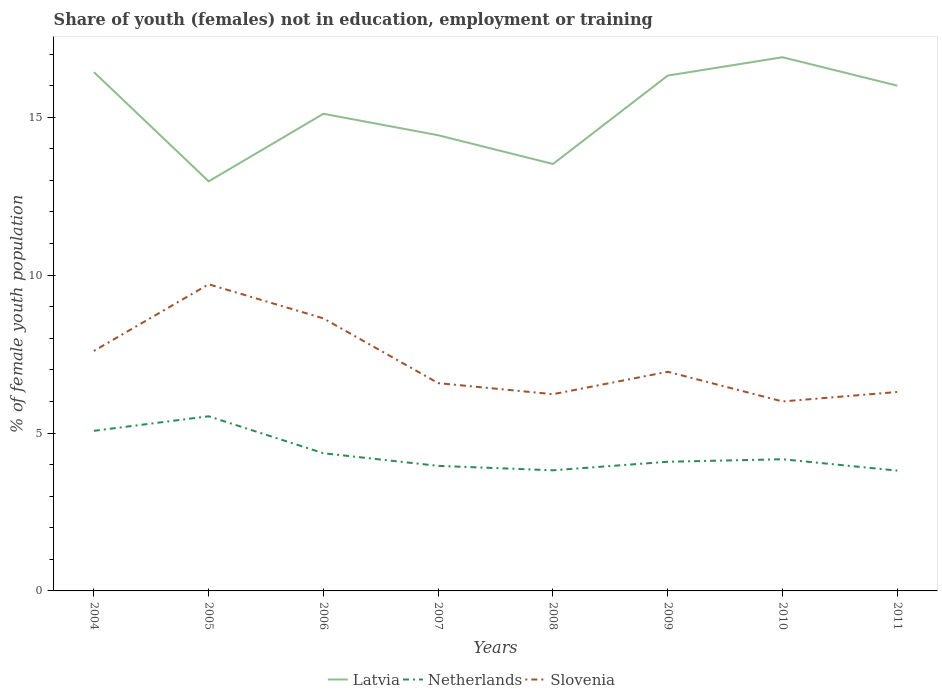Is the number of lines equal to the number of legend labels?
Offer a very short reply. Yes. Across all years, what is the maximum percentage of unemployed female population in in Latvia?
Ensure brevity in your answer.  12.97. In which year was the percentage of unemployed female population in in Slovenia maximum?
Offer a very short reply. 2010. What is the total percentage of unemployed female population in in Latvia in the graph?
Provide a succinct answer. 2.91. What is the difference between the highest and the second highest percentage of unemployed female population in in Netherlands?
Your response must be concise. 1.72. What is the difference between the highest and the lowest percentage of unemployed female population in in Netherlands?
Your answer should be very brief. 3. How many lines are there?
Offer a terse response. 3. How many years are there in the graph?
Provide a succinct answer. 8. What is the difference between two consecutive major ticks on the Y-axis?
Your answer should be compact. 5. Does the graph contain any zero values?
Offer a very short reply. No. Where does the legend appear in the graph?
Provide a succinct answer. Bottom center. How many legend labels are there?
Offer a terse response. 3. What is the title of the graph?
Provide a succinct answer. Share of youth (females) not in education, employment or training. Does "Barbados" appear as one of the legend labels in the graph?
Ensure brevity in your answer.  No. What is the label or title of the Y-axis?
Your answer should be compact. % of female youth population. What is the % of female youth population in Latvia in 2004?
Provide a short and direct response. 16.43. What is the % of female youth population of Netherlands in 2004?
Ensure brevity in your answer.  5.07. What is the % of female youth population in Slovenia in 2004?
Keep it short and to the point. 7.6. What is the % of female youth population in Latvia in 2005?
Make the answer very short. 12.97. What is the % of female youth population in Netherlands in 2005?
Ensure brevity in your answer.  5.53. What is the % of female youth population in Slovenia in 2005?
Provide a short and direct response. 9.71. What is the % of female youth population in Latvia in 2006?
Your answer should be very brief. 15.11. What is the % of female youth population of Netherlands in 2006?
Keep it short and to the point. 4.36. What is the % of female youth population of Slovenia in 2006?
Your response must be concise. 8.63. What is the % of female youth population of Latvia in 2007?
Provide a succinct answer. 14.43. What is the % of female youth population in Netherlands in 2007?
Provide a succinct answer. 3.96. What is the % of female youth population of Slovenia in 2007?
Keep it short and to the point. 6.58. What is the % of female youth population of Latvia in 2008?
Make the answer very short. 13.52. What is the % of female youth population of Netherlands in 2008?
Give a very brief answer. 3.82. What is the % of female youth population in Slovenia in 2008?
Your response must be concise. 6.23. What is the % of female youth population of Latvia in 2009?
Provide a short and direct response. 16.32. What is the % of female youth population in Netherlands in 2009?
Ensure brevity in your answer.  4.09. What is the % of female youth population of Slovenia in 2009?
Your answer should be compact. 6.94. What is the % of female youth population in Latvia in 2010?
Offer a very short reply. 16.9. What is the % of female youth population of Netherlands in 2010?
Offer a very short reply. 4.17. What is the % of female youth population of Slovenia in 2010?
Give a very brief answer. 6. What is the % of female youth population of Latvia in 2011?
Make the answer very short. 16. What is the % of female youth population of Netherlands in 2011?
Give a very brief answer. 3.81. What is the % of female youth population in Slovenia in 2011?
Offer a very short reply. 6.3. Across all years, what is the maximum % of female youth population of Latvia?
Provide a succinct answer. 16.9. Across all years, what is the maximum % of female youth population of Netherlands?
Keep it short and to the point. 5.53. Across all years, what is the maximum % of female youth population of Slovenia?
Provide a succinct answer. 9.71. Across all years, what is the minimum % of female youth population of Latvia?
Offer a terse response. 12.97. Across all years, what is the minimum % of female youth population of Netherlands?
Your answer should be very brief. 3.81. What is the total % of female youth population of Latvia in the graph?
Give a very brief answer. 121.68. What is the total % of female youth population in Netherlands in the graph?
Ensure brevity in your answer.  34.81. What is the total % of female youth population of Slovenia in the graph?
Ensure brevity in your answer.  57.99. What is the difference between the % of female youth population in Latvia in 2004 and that in 2005?
Your answer should be compact. 3.46. What is the difference between the % of female youth population in Netherlands in 2004 and that in 2005?
Keep it short and to the point. -0.46. What is the difference between the % of female youth population in Slovenia in 2004 and that in 2005?
Make the answer very short. -2.11. What is the difference between the % of female youth population in Latvia in 2004 and that in 2006?
Offer a very short reply. 1.32. What is the difference between the % of female youth population in Netherlands in 2004 and that in 2006?
Your response must be concise. 0.71. What is the difference between the % of female youth population of Slovenia in 2004 and that in 2006?
Make the answer very short. -1.03. What is the difference between the % of female youth population in Netherlands in 2004 and that in 2007?
Provide a succinct answer. 1.11. What is the difference between the % of female youth population in Latvia in 2004 and that in 2008?
Your response must be concise. 2.91. What is the difference between the % of female youth population in Slovenia in 2004 and that in 2008?
Provide a succinct answer. 1.37. What is the difference between the % of female youth population in Latvia in 2004 and that in 2009?
Ensure brevity in your answer.  0.11. What is the difference between the % of female youth population of Netherlands in 2004 and that in 2009?
Give a very brief answer. 0.98. What is the difference between the % of female youth population of Slovenia in 2004 and that in 2009?
Keep it short and to the point. 0.66. What is the difference between the % of female youth population of Latvia in 2004 and that in 2010?
Offer a terse response. -0.47. What is the difference between the % of female youth population of Netherlands in 2004 and that in 2010?
Provide a succinct answer. 0.9. What is the difference between the % of female youth population in Latvia in 2004 and that in 2011?
Offer a terse response. 0.43. What is the difference between the % of female youth population of Netherlands in 2004 and that in 2011?
Offer a terse response. 1.26. What is the difference between the % of female youth population of Slovenia in 2004 and that in 2011?
Keep it short and to the point. 1.3. What is the difference between the % of female youth population in Latvia in 2005 and that in 2006?
Give a very brief answer. -2.14. What is the difference between the % of female youth population of Netherlands in 2005 and that in 2006?
Offer a terse response. 1.17. What is the difference between the % of female youth population of Latvia in 2005 and that in 2007?
Your answer should be very brief. -1.46. What is the difference between the % of female youth population in Netherlands in 2005 and that in 2007?
Offer a terse response. 1.57. What is the difference between the % of female youth population in Slovenia in 2005 and that in 2007?
Offer a very short reply. 3.13. What is the difference between the % of female youth population in Latvia in 2005 and that in 2008?
Make the answer very short. -0.55. What is the difference between the % of female youth population in Netherlands in 2005 and that in 2008?
Provide a succinct answer. 1.71. What is the difference between the % of female youth population of Slovenia in 2005 and that in 2008?
Provide a short and direct response. 3.48. What is the difference between the % of female youth population in Latvia in 2005 and that in 2009?
Offer a very short reply. -3.35. What is the difference between the % of female youth population of Netherlands in 2005 and that in 2009?
Your answer should be compact. 1.44. What is the difference between the % of female youth population in Slovenia in 2005 and that in 2009?
Offer a very short reply. 2.77. What is the difference between the % of female youth population of Latvia in 2005 and that in 2010?
Offer a very short reply. -3.93. What is the difference between the % of female youth population of Netherlands in 2005 and that in 2010?
Offer a terse response. 1.36. What is the difference between the % of female youth population in Slovenia in 2005 and that in 2010?
Provide a succinct answer. 3.71. What is the difference between the % of female youth population of Latvia in 2005 and that in 2011?
Provide a short and direct response. -3.03. What is the difference between the % of female youth population in Netherlands in 2005 and that in 2011?
Provide a succinct answer. 1.72. What is the difference between the % of female youth population in Slovenia in 2005 and that in 2011?
Offer a very short reply. 3.41. What is the difference between the % of female youth population of Latvia in 2006 and that in 2007?
Keep it short and to the point. 0.68. What is the difference between the % of female youth population in Slovenia in 2006 and that in 2007?
Offer a terse response. 2.05. What is the difference between the % of female youth population in Latvia in 2006 and that in 2008?
Provide a succinct answer. 1.59. What is the difference between the % of female youth population in Netherlands in 2006 and that in 2008?
Keep it short and to the point. 0.54. What is the difference between the % of female youth population of Slovenia in 2006 and that in 2008?
Give a very brief answer. 2.4. What is the difference between the % of female youth population in Latvia in 2006 and that in 2009?
Your response must be concise. -1.21. What is the difference between the % of female youth population in Netherlands in 2006 and that in 2009?
Give a very brief answer. 0.27. What is the difference between the % of female youth population of Slovenia in 2006 and that in 2009?
Offer a very short reply. 1.69. What is the difference between the % of female youth population of Latvia in 2006 and that in 2010?
Your answer should be compact. -1.79. What is the difference between the % of female youth population in Netherlands in 2006 and that in 2010?
Your answer should be compact. 0.19. What is the difference between the % of female youth population in Slovenia in 2006 and that in 2010?
Give a very brief answer. 2.63. What is the difference between the % of female youth population of Latvia in 2006 and that in 2011?
Offer a terse response. -0.89. What is the difference between the % of female youth population in Netherlands in 2006 and that in 2011?
Your answer should be very brief. 0.55. What is the difference between the % of female youth population of Slovenia in 2006 and that in 2011?
Offer a terse response. 2.33. What is the difference between the % of female youth population of Latvia in 2007 and that in 2008?
Keep it short and to the point. 0.91. What is the difference between the % of female youth population in Netherlands in 2007 and that in 2008?
Your answer should be very brief. 0.14. What is the difference between the % of female youth population in Slovenia in 2007 and that in 2008?
Give a very brief answer. 0.35. What is the difference between the % of female youth population of Latvia in 2007 and that in 2009?
Provide a succinct answer. -1.89. What is the difference between the % of female youth population of Netherlands in 2007 and that in 2009?
Ensure brevity in your answer.  -0.13. What is the difference between the % of female youth population in Slovenia in 2007 and that in 2009?
Keep it short and to the point. -0.36. What is the difference between the % of female youth population in Latvia in 2007 and that in 2010?
Keep it short and to the point. -2.47. What is the difference between the % of female youth population of Netherlands in 2007 and that in 2010?
Offer a terse response. -0.21. What is the difference between the % of female youth population of Slovenia in 2007 and that in 2010?
Your answer should be compact. 0.58. What is the difference between the % of female youth population of Latvia in 2007 and that in 2011?
Ensure brevity in your answer.  -1.57. What is the difference between the % of female youth population of Slovenia in 2007 and that in 2011?
Make the answer very short. 0.28. What is the difference between the % of female youth population in Netherlands in 2008 and that in 2009?
Your response must be concise. -0.27. What is the difference between the % of female youth population in Slovenia in 2008 and that in 2009?
Your response must be concise. -0.71. What is the difference between the % of female youth population in Latvia in 2008 and that in 2010?
Provide a short and direct response. -3.38. What is the difference between the % of female youth population of Netherlands in 2008 and that in 2010?
Ensure brevity in your answer.  -0.35. What is the difference between the % of female youth population in Slovenia in 2008 and that in 2010?
Keep it short and to the point. 0.23. What is the difference between the % of female youth population of Latvia in 2008 and that in 2011?
Your answer should be compact. -2.48. What is the difference between the % of female youth population of Slovenia in 2008 and that in 2011?
Your response must be concise. -0.07. What is the difference between the % of female youth population in Latvia in 2009 and that in 2010?
Offer a terse response. -0.58. What is the difference between the % of female youth population in Netherlands in 2009 and that in 2010?
Offer a terse response. -0.08. What is the difference between the % of female youth population of Slovenia in 2009 and that in 2010?
Keep it short and to the point. 0.94. What is the difference between the % of female youth population in Latvia in 2009 and that in 2011?
Ensure brevity in your answer.  0.32. What is the difference between the % of female youth population of Netherlands in 2009 and that in 2011?
Provide a succinct answer. 0.28. What is the difference between the % of female youth population of Slovenia in 2009 and that in 2011?
Your response must be concise. 0.64. What is the difference between the % of female youth population in Netherlands in 2010 and that in 2011?
Provide a short and direct response. 0.36. What is the difference between the % of female youth population of Slovenia in 2010 and that in 2011?
Your answer should be very brief. -0.3. What is the difference between the % of female youth population in Latvia in 2004 and the % of female youth population in Slovenia in 2005?
Offer a terse response. 6.72. What is the difference between the % of female youth population in Netherlands in 2004 and the % of female youth population in Slovenia in 2005?
Give a very brief answer. -4.64. What is the difference between the % of female youth population in Latvia in 2004 and the % of female youth population in Netherlands in 2006?
Your response must be concise. 12.07. What is the difference between the % of female youth population of Latvia in 2004 and the % of female youth population of Slovenia in 2006?
Your answer should be very brief. 7.8. What is the difference between the % of female youth population in Netherlands in 2004 and the % of female youth population in Slovenia in 2006?
Offer a very short reply. -3.56. What is the difference between the % of female youth population of Latvia in 2004 and the % of female youth population of Netherlands in 2007?
Offer a very short reply. 12.47. What is the difference between the % of female youth population of Latvia in 2004 and the % of female youth population of Slovenia in 2007?
Provide a succinct answer. 9.85. What is the difference between the % of female youth population of Netherlands in 2004 and the % of female youth population of Slovenia in 2007?
Provide a succinct answer. -1.51. What is the difference between the % of female youth population in Latvia in 2004 and the % of female youth population in Netherlands in 2008?
Your answer should be very brief. 12.61. What is the difference between the % of female youth population of Netherlands in 2004 and the % of female youth population of Slovenia in 2008?
Offer a very short reply. -1.16. What is the difference between the % of female youth population in Latvia in 2004 and the % of female youth population in Netherlands in 2009?
Offer a terse response. 12.34. What is the difference between the % of female youth population of Latvia in 2004 and the % of female youth population of Slovenia in 2009?
Provide a short and direct response. 9.49. What is the difference between the % of female youth population of Netherlands in 2004 and the % of female youth population of Slovenia in 2009?
Keep it short and to the point. -1.87. What is the difference between the % of female youth population in Latvia in 2004 and the % of female youth population in Netherlands in 2010?
Your response must be concise. 12.26. What is the difference between the % of female youth population of Latvia in 2004 and the % of female youth population of Slovenia in 2010?
Your answer should be compact. 10.43. What is the difference between the % of female youth population in Netherlands in 2004 and the % of female youth population in Slovenia in 2010?
Your answer should be very brief. -0.93. What is the difference between the % of female youth population in Latvia in 2004 and the % of female youth population in Netherlands in 2011?
Offer a terse response. 12.62. What is the difference between the % of female youth population in Latvia in 2004 and the % of female youth population in Slovenia in 2011?
Provide a short and direct response. 10.13. What is the difference between the % of female youth population of Netherlands in 2004 and the % of female youth population of Slovenia in 2011?
Ensure brevity in your answer.  -1.23. What is the difference between the % of female youth population in Latvia in 2005 and the % of female youth population in Netherlands in 2006?
Give a very brief answer. 8.61. What is the difference between the % of female youth population of Latvia in 2005 and the % of female youth population of Slovenia in 2006?
Offer a terse response. 4.34. What is the difference between the % of female youth population of Netherlands in 2005 and the % of female youth population of Slovenia in 2006?
Provide a short and direct response. -3.1. What is the difference between the % of female youth population in Latvia in 2005 and the % of female youth population in Netherlands in 2007?
Make the answer very short. 9.01. What is the difference between the % of female youth population in Latvia in 2005 and the % of female youth population in Slovenia in 2007?
Offer a terse response. 6.39. What is the difference between the % of female youth population in Netherlands in 2005 and the % of female youth population in Slovenia in 2007?
Keep it short and to the point. -1.05. What is the difference between the % of female youth population in Latvia in 2005 and the % of female youth population in Netherlands in 2008?
Make the answer very short. 9.15. What is the difference between the % of female youth population in Latvia in 2005 and the % of female youth population in Slovenia in 2008?
Your answer should be compact. 6.74. What is the difference between the % of female youth population of Latvia in 2005 and the % of female youth population of Netherlands in 2009?
Provide a short and direct response. 8.88. What is the difference between the % of female youth population in Latvia in 2005 and the % of female youth population in Slovenia in 2009?
Your answer should be compact. 6.03. What is the difference between the % of female youth population of Netherlands in 2005 and the % of female youth population of Slovenia in 2009?
Offer a very short reply. -1.41. What is the difference between the % of female youth population in Latvia in 2005 and the % of female youth population in Slovenia in 2010?
Offer a terse response. 6.97. What is the difference between the % of female youth population in Netherlands in 2005 and the % of female youth population in Slovenia in 2010?
Keep it short and to the point. -0.47. What is the difference between the % of female youth population of Latvia in 2005 and the % of female youth population of Netherlands in 2011?
Offer a terse response. 9.16. What is the difference between the % of female youth population of Latvia in 2005 and the % of female youth population of Slovenia in 2011?
Ensure brevity in your answer.  6.67. What is the difference between the % of female youth population of Netherlands in 2005 and the % of female youth population of Slovenia in 2011?
Offer a terse response. -0.77. What is the difference between the % of female youth population of Latvia in 2006 and the % of female youth population of Netherlands in 2007?
Provide a succinct answer. 11.15. What is the difference between the % of female youth population in Latvia in 2006 and the % of female youth population in Slovenia in 2007?
Provide a short and direct response. 8.53. What is the difference between the % of female youth population in Netherlands in 2006 and the % of female youth population in Slovenia in 2007?
Give a very brief answer. -2.22. What is the difference between the % of female youth population in Latvia in 2006 and the % of female youth population in Netherlands in 2008?
Keep it short and to the point. 11.29. What is the difference between the % of female youth population in Latvia in 2006 and the % of female youth population in Slovenia in 2008?
Offer a terse response. 8.88. What is the difference between the % of female youth population of Netherlands in 2006 and the % of female youth population of Slovenia in 2008?
Give a very brief answer. -1.87. What is the difference between the % of female youth population in Latvia in 2006 and the % of female youth population in Netherlands in 2009?
Keep it short and to the point. 11.02. What is the difference between the % of female youth population of Latvia in 2006 and the % of female youth population of Slovenia in 2009?
Your answer should be compact. 8.17. What is the difference between the % of female youth population in Netherlands in 2006 and the % of female youth population in Slovenia in 2009?
Keep it short and to the point. -2.58. What is the difference between the % of female youth population in Latvia in 2006 and the % of female youth population in Netherlands in 2010?
Offer a very short reply. 10.94. What is the difference between the % of female youth population of Latvia in 2006 and the % of female youth population of Slovenia in 2010?
Make the answer very short. 9.11. What is the difference between the % of female youth population of Netherlands in 2006 and the % of female youth population of Slovenia in 2010?
Your answer should be compact. -1.64. What is the difference between the % of female youth population of Latvia in 2006 and the % of female youth population of Slovenia in 2011?
Ensure brevity in your answer.  8.81. What is the difference between the % of female youth population of Netherlands in 2006 and the % of female youth population of Slovenia in 2011?
Your answer should be compact. -1.94. What is the difference between the % of female youth population in Latvia in 2007 and the % of female youth population in Netherlands in 2008?
Provide a short and direct response. 10.61. What is the difference between the % of female youth population of Netherlands in 2007 and the % of female youth population of Slovenia in 2008?
Give a very brief answer. -2.27. What is the difference between the % of female youth population in Latvia in 2007 and the % of female youth population in Netherlands in 2009?
Provide a short and direct response. 10.34. What is the difference between the % of female youth population in Latvia in 2007 and the % of female youth population in Slovenia in 2009?
Your response must be concise. 7.49. What is the difference between the % of female youth population of Netherlands in 2007 and the % of female youth population of Slovenia in 2009?
Your response must be concise. -2.98. What is the difference between the % of female youth population in Latvia in 2007 and the % of female youth population in Netherlands in 2010?
Make the answer very short. 10.26. What is the difference between the % of female youth population of Latvia in 2007 and the % of female youth population of Slovenia in 2010?
Offer a very short reply. 8.43. What is the difference between the % of female youth population in Netherlands in 2007 and the % of female youth population in Slovenia in 2010?
Your answer should be compact. -2.04. What is the difference between the % of female youth population in Latvia in 2007 and the % of female youth population in Netherlands in 2011?
Your response must be concise. 10.62. What is the difference between the % of female youth population in Latvia in 2007 and the % of female youth population in Slovenia in 2011?
Make the answer very short. 8.13. What is the difference between the % of female youth population of Netherlands in 2007 and the % of female youth population of Slovenia in 2011?
Your response must be concise. -2.34. What is the difference between the % of female youth population in Latvia in 2008 and the % of female youth population in Netherlands in 2009?
Your response must be concise. 9.43. What is the difference between the % of female youth population of Latvia in 2008 and the % of female youth population of Slovenia in 2009?
Make the answer very short. 6.58. What is the difference between the % of female youth population of Netherlands in 2008 and the % of female youth population of Slovenia in 2009?
Provide a succinct answer. -3.12. What is the difference between the % of female youth population of Latvia in 2008 and the % of female youth population of Netherlands in 2010?
Keep it short and to the point. 9.35. What is the difference between the % of female youth population of Latvia in 2008 and the % of female youth population of Slovenia in 2010?
Provide a succinct answer. 7.52. What is the difference between the % of female youth population of Netherlands in 2008 and the % of female youth population of Slovenia in 2010?
Offer a terse response. -2.18. What is the difference between the % of female youth population in Latvia in 2008 and the % of female youth population in Netherlands in 2011?
Keep it short and to the point. 9.71. What is the difference between the % of female youth population of Latvia in 2008 and the % of female youth population of Slovenia in 2011?
Make the answer very short. 7.22. What is the difference between the % of female youth population in Netherlands in 2008 and the % of female youth population in Slovenia in 2011?
Offer a terse response. -2.48. What is the difference between the % of female youth population of Latvia in 2009 and the % of female youth population of Netherlands in 2010?
Provide a succinct answer. 12.15. What is the difference between the % of female youth population of Latvia in 2009 and the % of female youth population of Slovenia in 2010?
Offer a very short reply. 10.32. What is the difference between the % of female youth population of Netherlands in 2009 and the % of female youth population of Slovenia in 2010?
Provide a succinct answer. -1.91. What is the difference between the % of female youth population of Latvia in 2009 and the % of female youth population of Netherlands in 2011?
Offer a terse response. 12.51. What is the difference between the % of female youth population of Latvia in 2009 and the % of female youth population of Slovenia in 2011?
Your response must be concise. 10.02. What is the difference between the % of female youth population in Netherlands in 2009 and the % of female youth population in Slovenia in 2011?
Provide a short and direct response. -2.21. What is the difference between the % of female youth population in Latvia in 2010 and the % of female youth population in Netherlands in 2011?
Offer a terse response. 13.09. What is the difference between the % of female youth population in Netherlands in 2010 and the % of female youth population in Slovenia in 2011?
Your response must be concise. -2.13. What is the average % of female youth population in Latvia per year?
Offer a terse response. 15.21. What is the average % of female youth population in Netherlands per year?
Give a very brief answer. 4.35. What is the average % of female youth population of Slovenia per year?
Offer a terse response. 7.25. In the year 2004, what is the difference between the % of female youth population in Latvia and % of female youth population in Netherlands?
Your answer should be compact. 11.36. In the year 2004, what is the difference between the % of female youth population of Latvia and % of female youth population of Slovenia?
Give a very brief answer. 8.83. In the year 2004, what is the difference between the % of female youth population in Netherlands and % of female youth population in Slovenia?
Offer a very short reply. -2.53. In the year 2005, what is the difference between the % of female youth population in Latvia and % of female youth population in Netherlands?
Make the answer very short. 7.44. In the year 2005, what is the difference between the % of female youth population in Latvia and % of female youth population in Slovenia?
Ensure brevity in your answer.  3.26. In the year 2005, what is the difference between the % of female youth population in Netherlands and % of female youth population in Slovenia?
Provide a succinct answer. -4.18. In the year 2006, what is the difference between the % of female youth population of Latvia and % of female youth population of Netherlands?
Keep it short and to the point. 10.75. In the year 2006, what is the difference between the % of female youth population of Latvia and % of female youth population of Slovenia?
Offer a very short reply. 6.48. In the year 2006, what is the difference between the % of female youth population of Netherlands and % of female youth population of Slovenia?
Your answer should be compact. -4.27. In the year 2007, what is the difference between the % of female youth population of Latvia and % of female youth population of Netherlands?
Offer a very short reply. 10.47. In the year 2007, what is the difference between the % of female youth population of Latvia and % of female youth population of Slovenia?
Your response must be concise. 7.85. In the year 2007, what is the difference between the % of female youth population in Netherlands and % of female youth population in Slovenia?
Your answer should be very brief. -2.62. In the year 2008, what is the difference between the % of female youth population of Latvia and % of female youth population of Slovenia?
Give a very brief answer. 7.29. In the year 2008, what is the difference between the % of female youth population of Netherlands and % of female youth population of Slovenia?
Ensure brevity in your answer.  -2.41. In the year 2009, what is the difference between the % of female youth population in Latvia and % of female youth population in Netherlands?
Your response must be concise. 12.23. In the year 2009, what is the difference between the % of female youth population of Latvia and % of female youth population of Slovenia?
Offer a terse response. 9.38. In the year 2009, what is the difference between the % of female youth population of Netherlands and % of female youth population of Slovenia?
Ensure brevity in your answer.  -2.85. In the year 2010, what is the difference between the % of female youth population in Latvia and % of female youth population in Netherlands?
Offer a terse response. 12.73. In the year 2010, what is the difference between the % of female youth population in Netherlands and % of female youth population in Slovenia?
Offer a very short reply. -1.83. In the year 2011, what is the difference between the % of female youth population in Latvia and % of female youth population in Netherlands?
Make the answer very short. 12.19. In the year 2011, what is the difference between the % of female youth population in Netherlands and % of female youth population in Slovenia?
Offer a very short reply. -2.49. What is the ratio of the % of female youth population in Latvia in 2004 to that in 2005?
Provide a short and direct response. 1.27. What is the ratio of the % of female youth population in Netherlands in 2004 to that in 2005?
Offer a terse response. 0.92. What is the ratio of the % of female youth population in Slovenia in 2004 to that in 2005?
Your response must be concise. 0.78. What is the ratio of the % of female youth population in Latvia in 2004 to that in 2006?
Your answer should be very brief. 1.09. What is the ratio of the % of female youth population of Netherlands in 2004 to that in 2006?
Your answer should be compact. 1.16. What is the ratio of the % of female youth population in Slovenia in 2004 to that in 2006?
Offer a very short reply. 0.88. What is the ratio of the % of female youth population of Latvia in 2004 to that in 2007?
Your response must be concise. 1.14. What is the ratio of the % of female youth population of Netherlands in 2004 to that in 2007?
Offer a very short reply. 1.28. What is the ratio of the % of female youth population of Slovenia in 2004 to that in 2007?
Your answer should be very brief. 1.16. What is the ratio of the % of female youth population of Latvia in 2004 to that in 2008?
Ensure brevity in your answer.  1.22. What is the ratio of the % of female youth population in Netherlands in 2004 to that in 2008?
Offer a terse response. 1.33. What is the ratio of the % of female youth population of Slovenia in 2004 to that in 2008?
Your response must be concise. 1.22. What is the ratio of the % of female youth population of Latvia in 2004 to that in 2009?
Make the answer very short. 1.01. What is the ratio of the % of female youth population in Netherlands in 2004 to that in 2009?
Your response must be concise. 1.24. What is the ratio of the % of female youth population in Slovenia in 2004 to that in 2009?
Your answer should be compact. 1.1. What is the ratio of the % of female youth population in Latvia in 2004 to that in 2010?
Offer a terse response. 0.97. What is the ratio of the % of female youth population of Netherlands in 2004 to that in 2010?
Ensure brevity in your answer.  1.22. What is the ratio of the % of female youth population in Slovenia in 2004 to that in 2010?
Make the answer very short. 1.27. What is the ratio of the % of female youth population of Latvia in 2004 to that in 2011?
Your response must be concise. 1.03. What is the ratio of the % of female youth population in Netherlands in 2004 to that in 2011?
Make the answer very short. 1.33. What is the ratio of the % of female youth population in Slovenia in 2004 to that in 2011?
Your response must be concise. 1.21. What is the ratio of the % of female youth population in Latvia in 2005 to that in 2006?
Provide a short and direct response. 0.86. What is the ratio of the % of female youth population of Netherlands in 2005 to that in 2006?
Provide a short and direct response. 1.27. What is the ratio of the % of female youth population of Slovenia in 2005 to that in 2006?
Give a very brief answer. 1.13. What is the ratio of the % of female youth population of Latvia in 2005 to that in 2007?
Give a very brief answer. 0.9. What is the ratio of the % of female youth population of Netherlands in 2005 to that in 2007?
Your answer should be compact. 1.4. What is the ratio of the % of female youth population of Slovenia in 2005 to that in 2007?
Keep it short and to the point. 1.48. What is the ratio of the % of female youth population in Latvia in 2005 to that in 2008?
Provide a short and direct response. 0.96. What is the ratio of the % of female youth population in Netherlands in 2005 to that in 2008?
Make the answer very short. 1.45. What is the ratio of the % of female youth population in Slovenia in 2005 to that in 2008?
Your answer should be very brief. 1.56. What is the ratio of the % of female youth population in Latvia in 2005 to that in 2009?
Provide a short and direct response. 0.79. What is the ratio of the % of female youth population in Netherlands in 2005 to that in 2009?
Ensure brevity in your answer.  1.35. What is the ratio of the % of female youth population in Slovenia in 2005 to that in 2009?
Offer a terse response. 1.4. What is the ratio of the % of female youth population in Latvia in 2005 to that in 2010?
Ensure brevity in your answer.  0.77. What is the ratio of the % of female youth population of Netherlands in 2005 to that in 2010?
Your answer should be very brief. 1.33. What is the ratio of the % of female youth population in Slovenia in 2005 to that in 2010?
Give a very brief answer. 1.62. What is the ratio of the % of female youth population of Latvia in 2005 to that in 2011?
Provide a short and direct response. 0.81. What is the ratio of the % of female youth population of Netherlands in 2005 to that in 2011?
Keep it short and to the point. 1.45. What is the ratio of the % of female youth population of Slovenia in 2005 to that in 2011?
Ensure brevity in your answer.  1.54. What is the ratio of the % of female youth population in Latvia in 2006 to that in 2007?
Keep it short and to the point. 1.05. What is the ratio of the % of female youth population in Netherlands in 2006 to that in 2007?
Your answer should be very brief. 1.1. What is the ratio of the % of female youth population of Slovenia in 2006 to that in 2007?
Provide a succinct answer. 1.31. What is the ratio of the % of female youth population in Latvia in 2006 to that in 2008?
Offer a terse response. 1.12. What is the ratio of the % of female youth population of Netherlands in 2006 to that in 2008?
Offer a very short reply. 1.14. What is the ratio of the % of female youth population in Slovenia in 2006 to that in 2008?
Offer a very short reply. 1.39. What is the ratio of the % of female youth population in Latvia in 2006 to that in 2009?
Provide a short and direct response. 0.93. What is the ratio of the % of female youth population in Netherlands in 2006 to that in 2009?
Keep it short and to the point. 1.07. What is the ratio of the % of female youth population in Slovenia in 2006 to that in 2009?
Provide a short and direct response. 1.24. What is the ratio of the % of female youth population in Latvia in 2006 to that in 2010?
Offer a very short reply. 0.89. What is the ratio of the % of female youth population in Netherlands in 2006 to that in 2010?
Provide a short and direct response. 1.05. What is the ratio of the % of female youth population in Slovenia in 2006 to that in 2010?
Your answer should be compact. 1.44. What is the ratio of the % of female youth population in Netherlands in 2006 to that in 2011?
Ensure brevity in your answer.  1.14. What is the ratio of the % of female youth population in Slovenia in 2006 to that in 2011?
Offer a very short reply. 1.37. What is the ratio of the % of female youth population of Latvia in 2007 to that in 2008?
Offer a terse response. 1.07. What is the ratio of the % of female youth population in Netherlands in 2007 to that in 2008?
Provide a succinct answer. 1.04. What is the ratio of the % of female youth population in Slovenia in 2007 to that in 2008?
Your answer should be very brief. 1.06. What is the ratio of the % of female youth population in Latvia in 2007 to that in 2009?
Provide a short and direct response. 0.88. What is the ratio of the % of female youth population in Netherlands in 2007 to that in 2009?
Your answer should be very brief. 0.97. What is the ratio of the % of female youth population of Slovenia in 2007 to that in 2009?
Your answer should be compact. 0.95. What is the ratio of the % of female youth population in Latvia in 2007 to that in 2010?
Offer a very short reply. 0.85. What is the ratio of the % of female youth population in Netherlands in 2007 to that in 2010?
Offer a very short reply. 0.95. What is the ratio of the % of female youth population of Slovenia in 2007 to that in 2010?
Provide a succinct answer. 1.1. What is the ratio of the % of female youth population in Latvia in 2007 to that in 2011?
Offer a very short reply. 0.9. What is the ratio of the % of female youth population of Netherlands in 2007 to that in 2011?
Offer a very short reply. 1.04. What is the ratio of the % of female youth population in Slovenia in 2007 to that in 2011?
Give a very brief answer. 1.04. What is the ratio of the % of female youth population in Latvia in 2008 to that in 2009?
Your response must be concise. 0.83. What is the ratio of the % of female youth population of Netherlands in 2008 to that in 2009?
Your response must be concise. 0.93. What is the ratio of the % of female youth population in Slovenia in 2008 to that in 2009?
Offer a very short reply. 0.9. What is the ratio of the % of female youth population in Netherlands in 2008 to that in 2010?
Offer a very short reply. 0.92. What is the ratio of the % of female youth population in Slovenia in 2008 to that in 2010?
Offer a very short reply. 1.04. What is the ratio of the % of female youth population of Latvia in 2008 to that in 2011?
Give a very brief answer. 0.84. What is the ratio of the % of female youth population in Netherlands in 2008 to that in 2011?
Provide a succinct answer. 1. What is the ratio of the % of female youth population of Slovenia in 2008 to that in 2011?
Your response must be concise. 0.99. What is the ratio of the % of female youth population in Latvia in 2009 to that in 2010?
Your answer should be very brief. 0.97. What is the ratio of the % of female youth population in Netherlands in 2009 to that in 2010?
Provide a succinct answer. 0.98. What is the ratio of the % of female youth population in Slovenia in 2009 to that in 2010?
Offer a very short reply. 1.16. What is the ratio of the % of female youth population in Latvia in 2009 to that in 2011?
Your answer should be compact. 1.02. What is the ratio of the % of female youth population in Netherlands in 2009 to that in 2011?
Offer a very short reply. 1.07. What is the ratio of the % of female youth population of Slovenia in 2009 to that in 2011?
Give a very brief answer. 1.1. What is the ratio of the % of female youth population in Latvia in 2010 to that in 2011?
Give a very brief answer. 1.06. What is the ratio of the % of female youth population of Netherlands in 2010 to that in 2011?
Offer a terse response. 1.09. What is the ratio of the % of female youth population of Slovenia in 2010 to that in 2011?
Give a very brief answer. 0.95. What is the difference between the highest and the second highest % of female youth population in Latvia?
Your response must be concise. 0.47. What is the difference between the highest and the second highest % of female youth population of Netherlands?
Provide a succinct answer. 0.46. What is the difference between the highest and the lowest % of female youth population of Latvia?
Your answer should be compact. 3.93. What is the difference between the highest and the lowest % of female youth population of Netherlands?
Ensure brevity in your answer.  1.72. What is the difference between the highest and the lowest % of female youth population of Slovenia?
Make the answer very short. 3.71. 